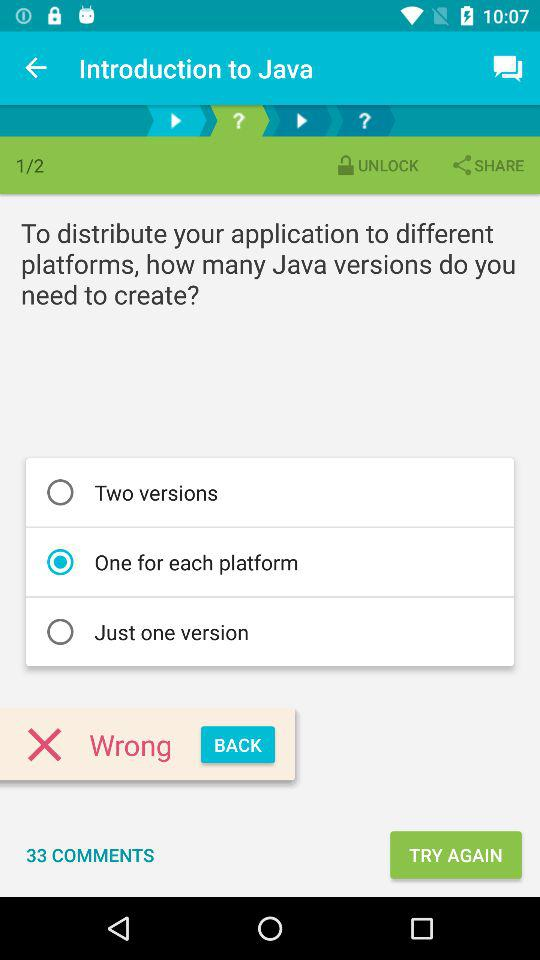How many options are there for creating a Java version?
Answer the question using a single word or phrase. 3 